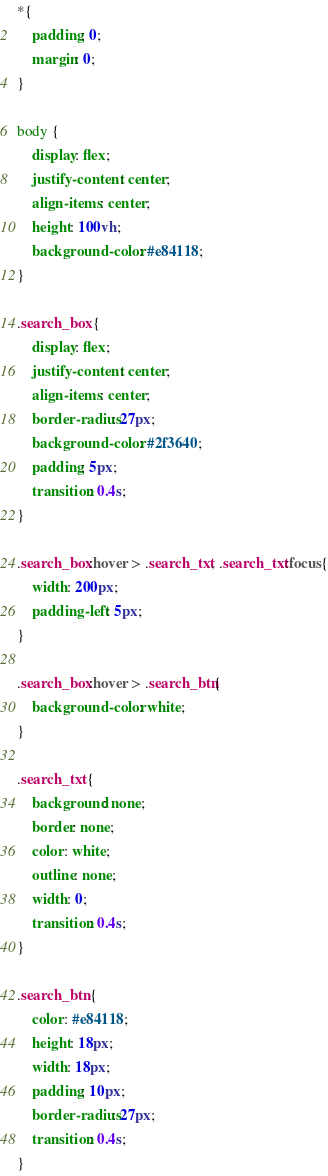<code> <loc_0><loc_0><loc_500><loc_500><_CSS_>*{
    padding: 0;
    margin: 0;
}

body {
    display: flex;
    justify-content: center;
    align-items: center;
    height: 100vh;
    background-color: #e84118;
}

.search_box {
    display: flex;
    justify-content: center;
    align-items: center;
    border-radius: 27px;
    background-color: #2f3640;
    padding: 5px;
    transition: 0.4s;
}

.search_box:hover > .search_txt, .search_txt:focus{
    width: 200px;
    padding-left: 5px;
}

.search_box:hover > .search_btn{
    background-color: white;
}

.search_txt {
    background: none;
    border: none;
    color: white;
    outline: none;
    width: 0;
    transition: 0.4s;
}

.search_btn {
    color: #e84118;
    height: 18px;
    width: 18px;
    padding: 10px;
    border-radius: 27px;
    transition: 0.4s;
}</code> 